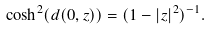Convert formula to latex. <formula><loc_0><loc_0><loc_500><loc_500>\cosh ^ { 2 } ( d ( 0 , z ) ) = ( 1 - | z | ^ { 2 } ) ^ { - 1 } .</formula> 